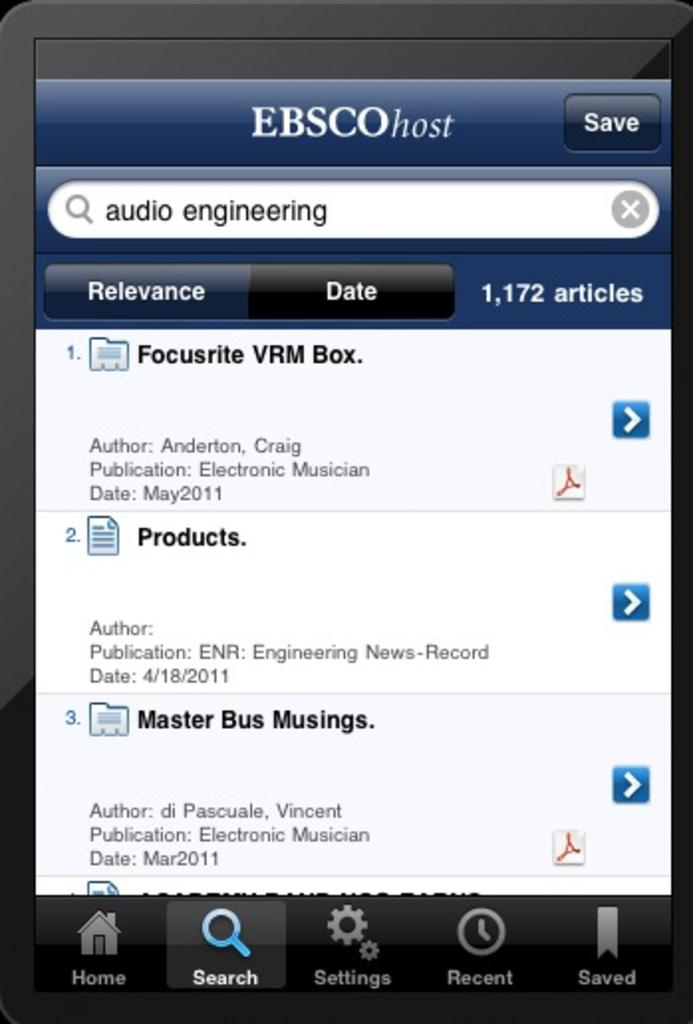<image>
Present a compact description of the photo's key features. phone screen showing search for audio engineering and 1172 articles resulting 